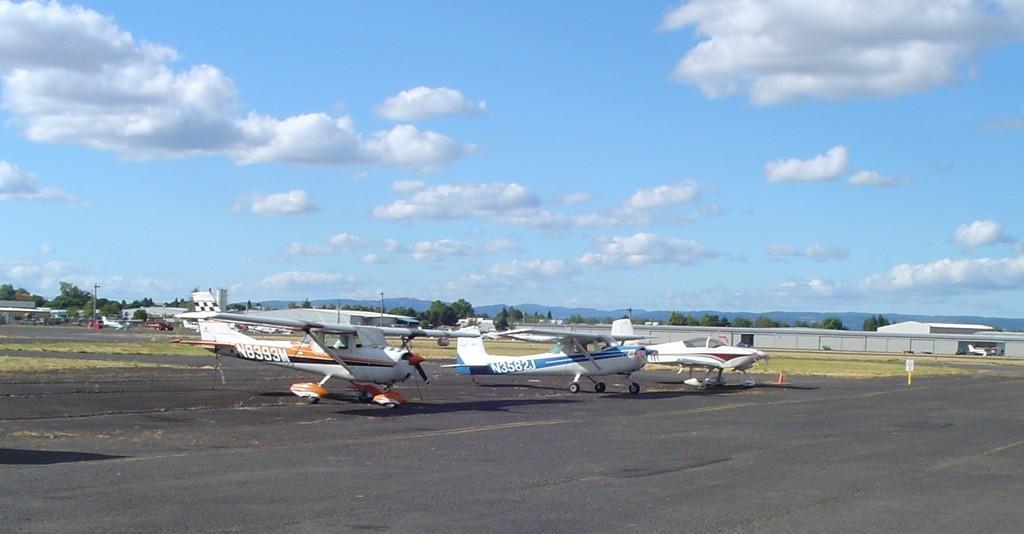What is the number of the blue and white planes?
Provide a succinct answer. N3582j. What's the name on the orange and white plate?
Keep it short and to the point. N8393m. 